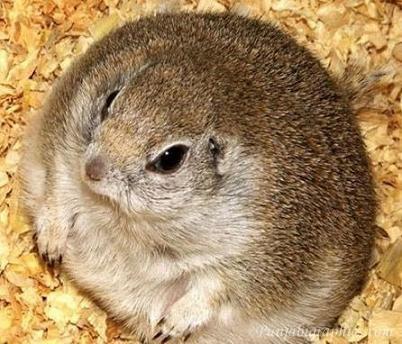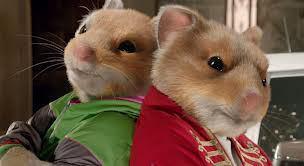The first image is the image on the left, the second image is the image on the right. Considering the images on both sides, is "There are two rodents in the image on the right." valid? Answer yes or no. Yes. The first image is the image on the left, the second image is the image on the right. Evaluate the accuracy of this statement regarding the images: "The right image contains exactly two mouse-like animals posed side-by-side with heads close together, and the left image contains something round and brown that nearly fills the space.". Is it true? Answer yes or no. Yes. 